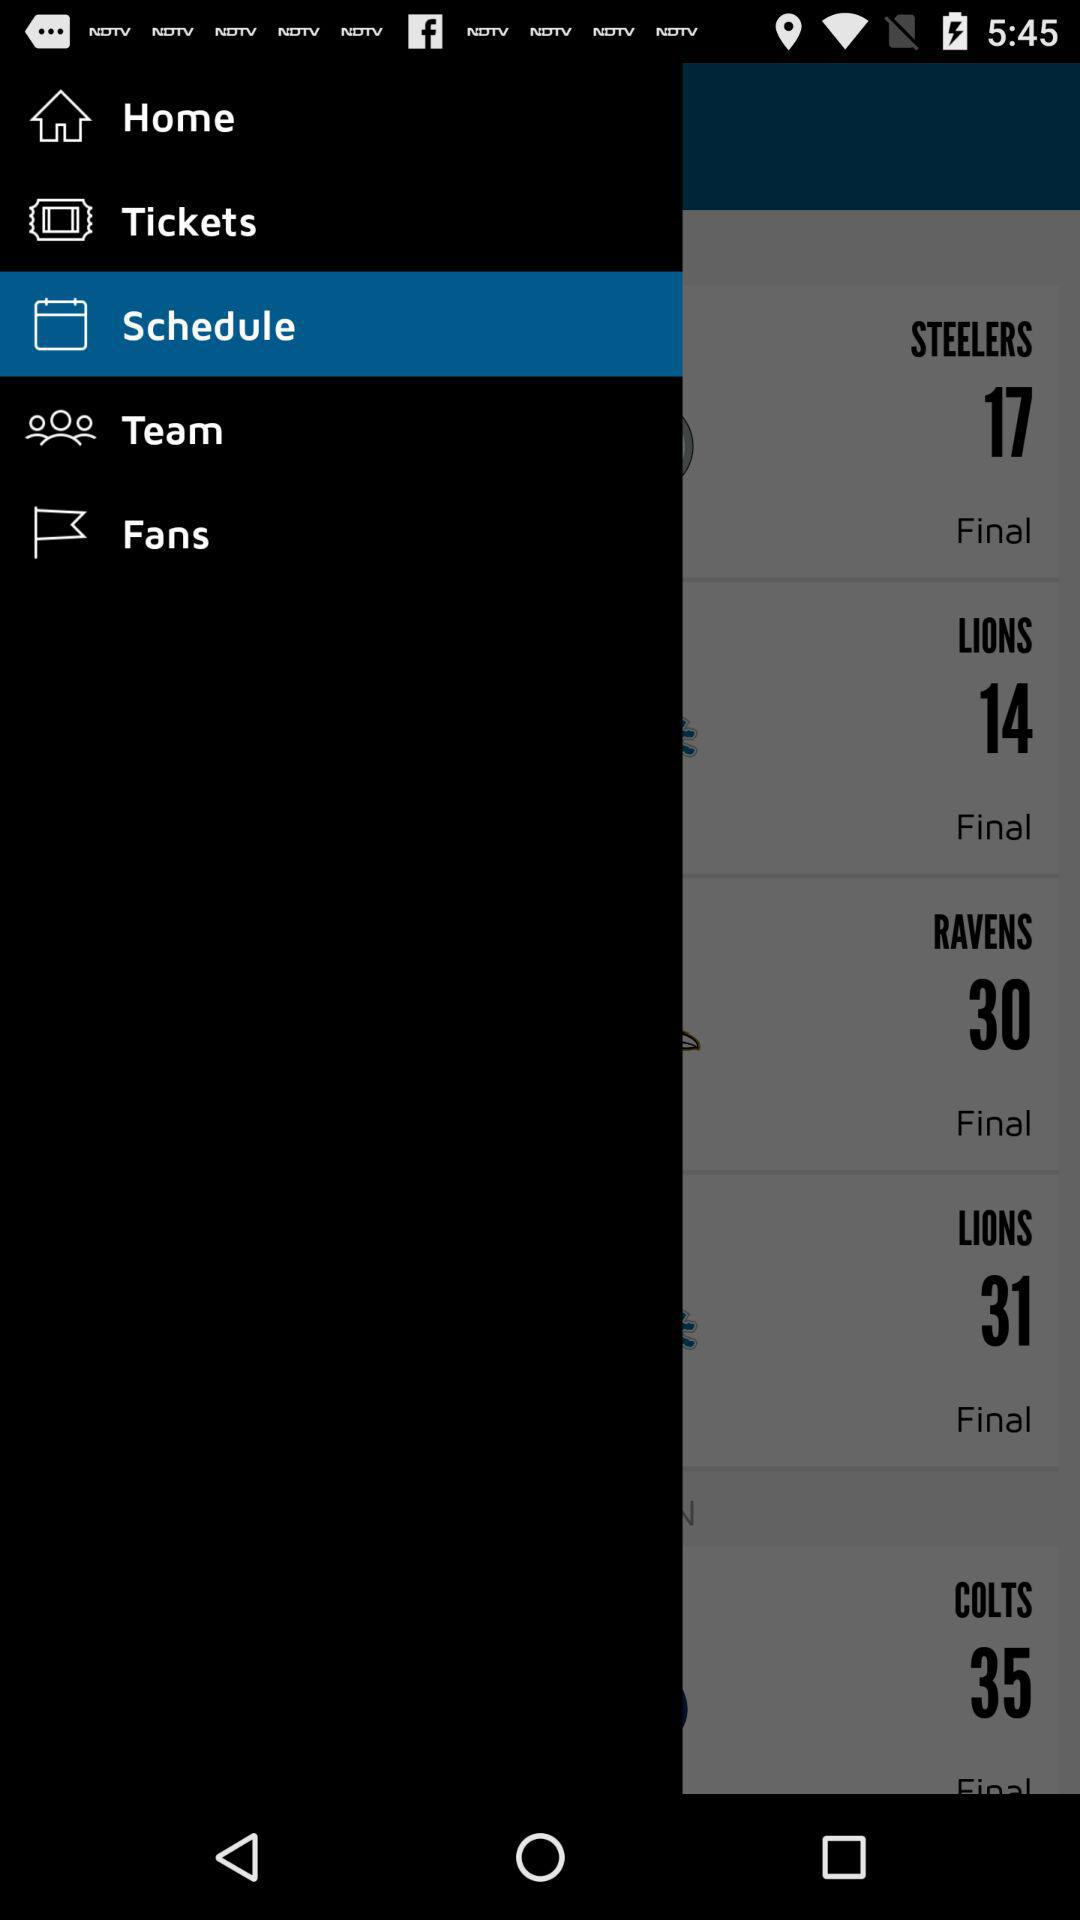Which item has been selected? The selected item is "Schedule". 